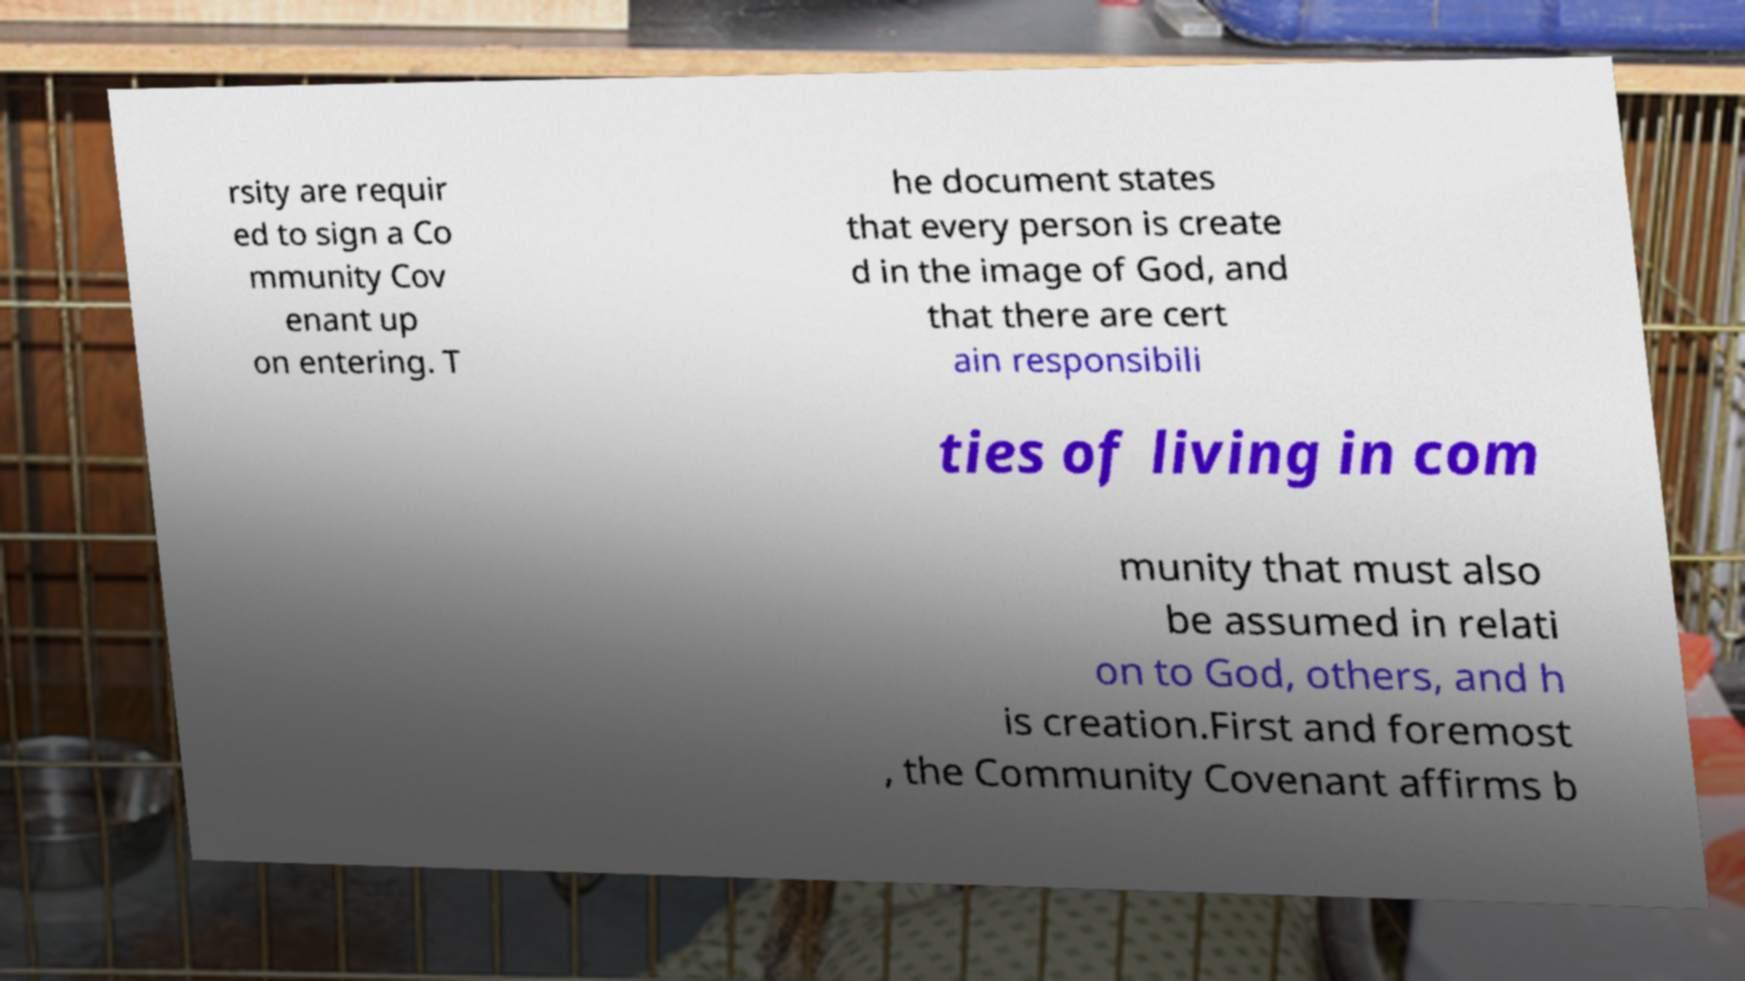Please identify and transcribe the text found in this image. rsity are requir ed to sign a Co mmunity Cov enant up on entering. T he document states that every person is create d in the image of God, and that there are cert ain responsibili ties of living in com munity that must also be assumed in relati on to God, others, and h is creation.First and foremost , the Community Covenant affirms b 